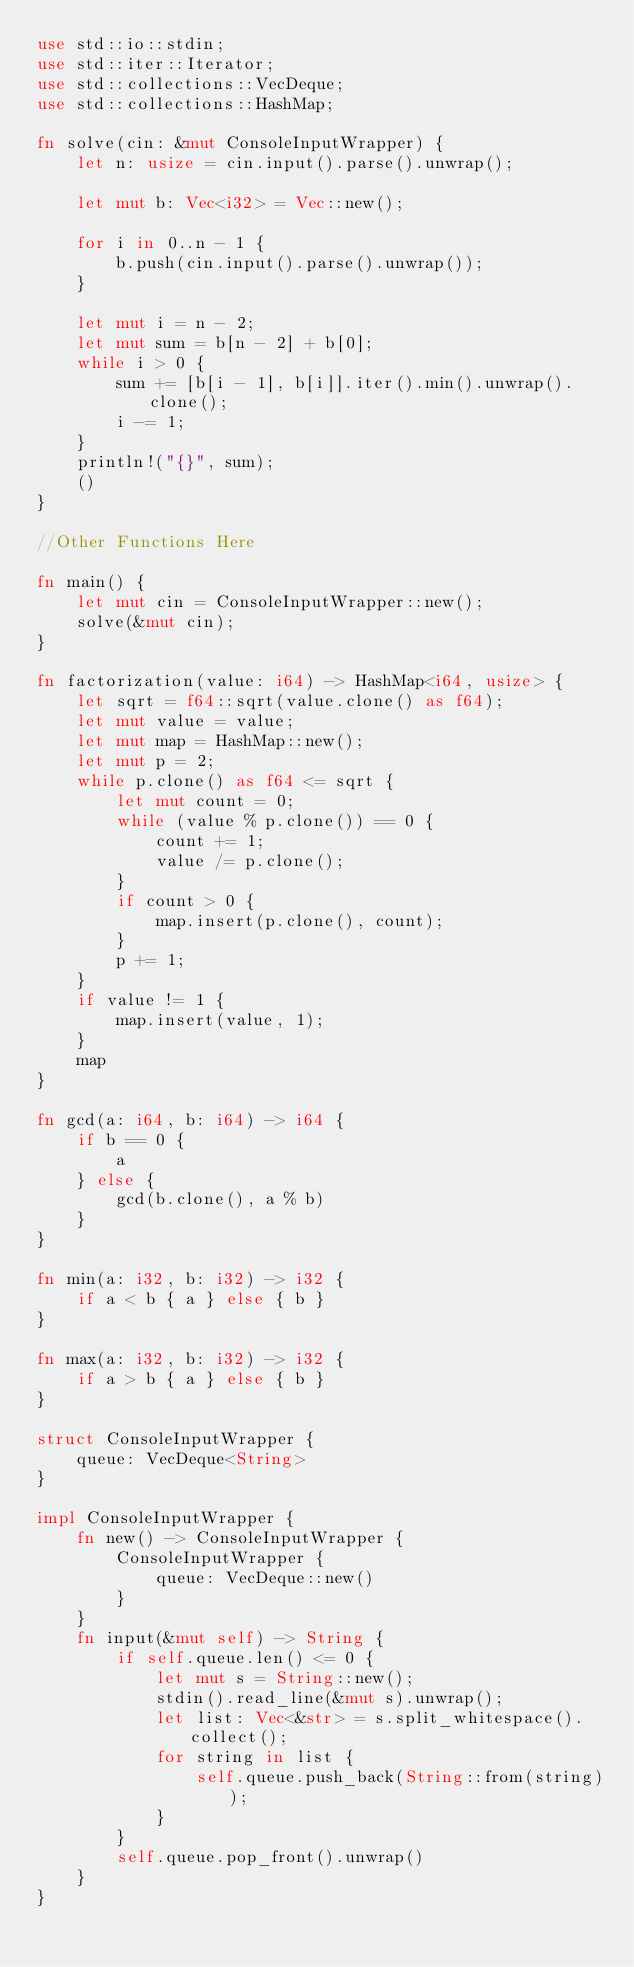Convert code to text. <code><loc_0><loc_0><loc_500><loc_500><_Rust_>use std::io::stdin;
use std::iter::Iterator;
use std::collections::VecDeque;
use std::collections::HashMap;

fn solve(cin: &mut ConsoleInputWrapper) {
    let n: usize = cin.input().parse().unwrap();

    let mut b: Vec<i32> = Vec::new();

    for i in 0..n - 1 {
        b.push(cin.input().parse().unwrap());
    }

    let mut i = n - 2;
    let mut sum = b[n - 2] + b[0];
    while i > 0 {
        sum += [b[i - 1], b[i]].iter().min().unwrap().clone();
        i -= 1;
    }
    println!("{}", sum);
    ()
}

//Other Functions Here

fn main() {
    let mut cin = ConsoleInputWrapper::new();
    solve(&mut cin);
}

fn factorization(value: i64) -> HashMap<i64, usize> {
    let sqrt = f64::sqrt(value.clone() as f64);
    let mut value = value;
    let mut map = HashMap::new();
    let mut p = 2;
    while p.clone() as f64 <= sqrt {
        let mut count = 0;
        while (value % p.clone()) == 0 {
            count += 1;
            value /= p.clone();
        }
        if count > 0 {
            map.insert(p.clone(), count);
        }
        p += 1;
    }
    if value != 1 {
        map.insert(value, 1);
    }
    map
}

fn gcd(a: i64, b: i64) -> i64 {
    if b == 0 {
        a
    } else {
        gcd(b.clone(), a % b)
    }
}

fn min(a: i32, b: i32) -> i32 {
    if a < b { a } else { b }
}

fn max(a: i32, b: i32) -> i32 {
    if a > b { a } else { b }
}

struct ConsoleInputWrapper {
    queue: VecDeque<String>
}

impl ConsoleInputWrapper {
    fn new() -> ConsoleInputWrapper {
        ConsoleInputWrapper {
            queue: VecDeque::new()
        }
    }
    fn input(&mut self) -> String {
        if self.queue.len() <= 0 {
            let mut s = String::new();
            stdin().read_line(&mut s).unwrap();
            let list: Vec<&str> = s.split_whitespace().collect();
            for string in list {
                self.queue.push_back(String::from(string));
            }
        }
        self.queue.pop_front().unwrap()
    }
}</code> 